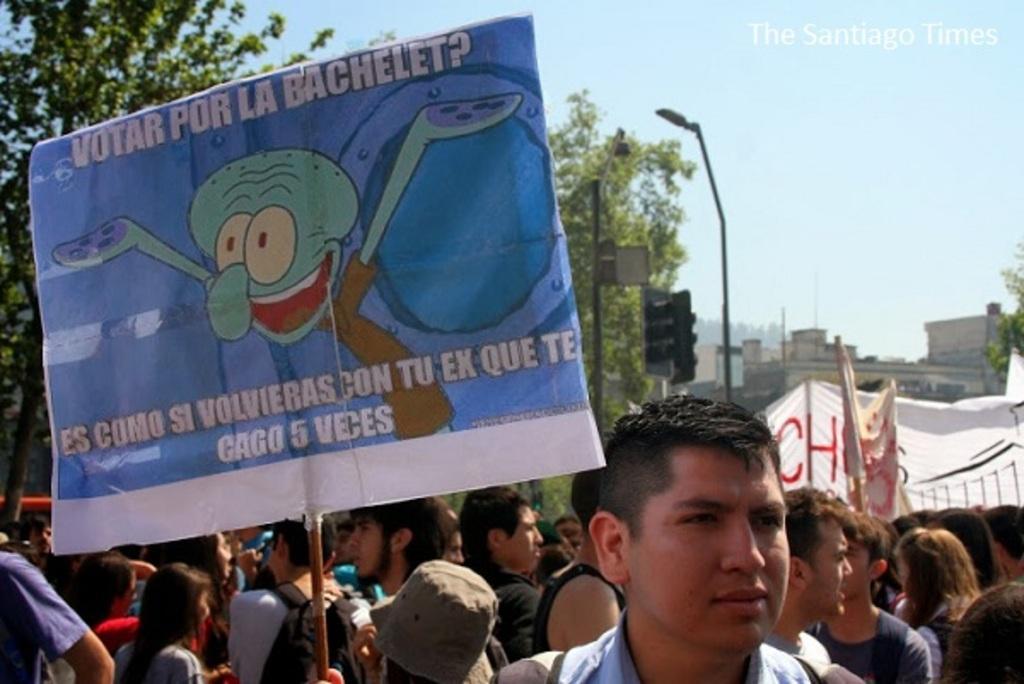Can you describe this image briefly? In the picture we can see a group of people standing on and one man is holding a board and In the background, we can see some poles with street lights and a traffic light and behind it, we can see some trees and buildings and in the background we can see a sky with clouds. 